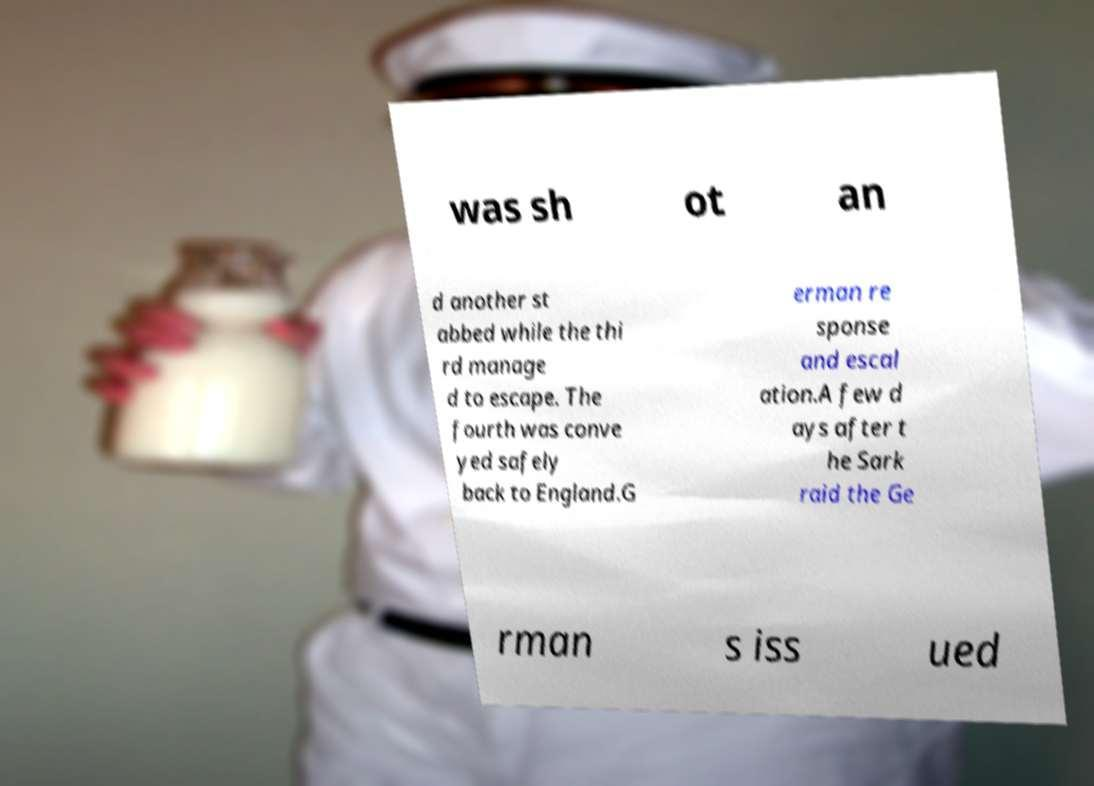I need the written content from this picture converted into text. Can you do that? was sh ot an d another st abbed while the thi rd manage d to escape. The fourth was conve yed safely back to England.G erman re sponse and escal ation.A few d ays after t he Sark raid the Ge rman s iss ued 